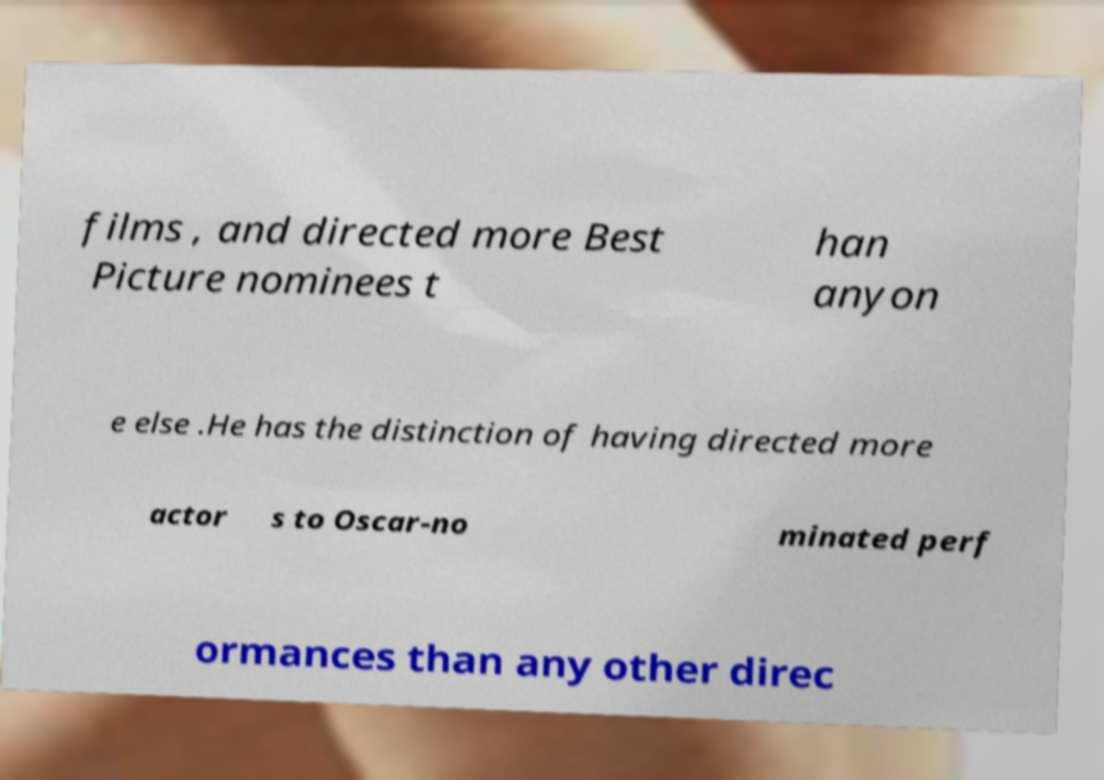Could you assist in decoding the text presented in this image and type it out clearly? films , and directed more Best Picture nominees t han anyon e else .He has the distinction of having directed more actor s to Oscar-no minated perf ormances than any other direc 